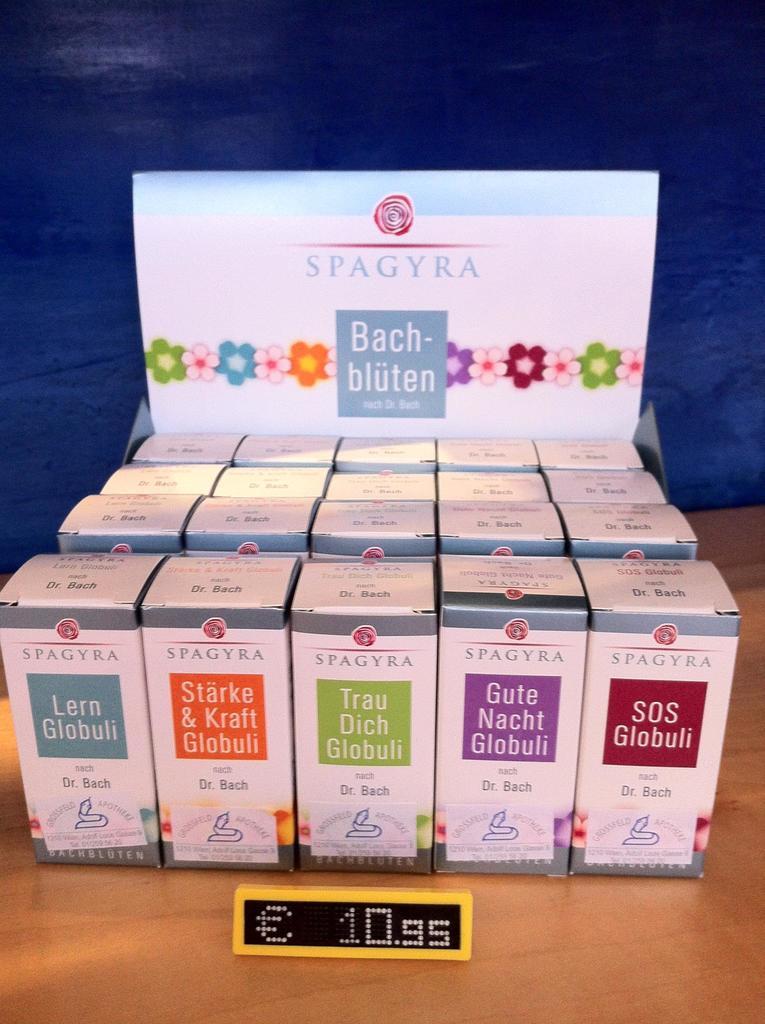How much does this cost?
Your response must be concise. 10.95. Who makes this product?
Your answer should be compact. Spagyra. 